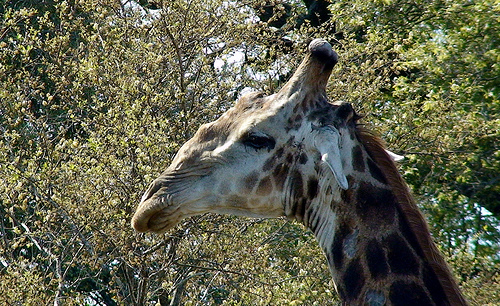<image>
Can you confirm if the giraffe is on the tree? No. The giraffe is not positioned on the tree. They may be near each other, but the giraffe is not supported by or resting on top of the tree. 